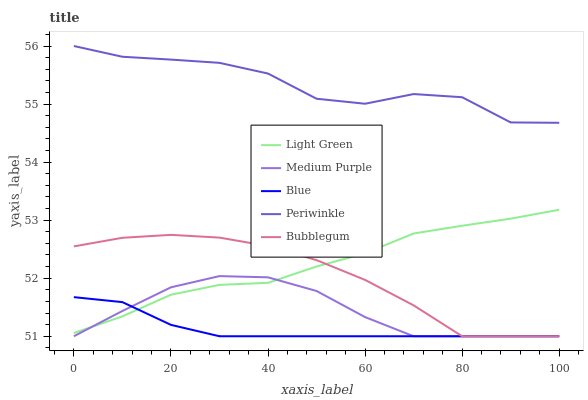Does Blue have the minimum area under the curve?
Answer yes or no. Yes. Does Periwinkle have the maximum area under the curve?
Answer yes or no. Yes. Does Periwinkle have the minimum area under the curve?
Answer yes or no. No. Does Blue have the maximum area under the curve?
Answer yes or no. No. Is Blue the smoothest?
Answer yes or no. Yes. Is Periwinkle the roughest?
Answer yes or no. Yes. Is Periwinkle the smoothest?
Answer yes or no. No. Is Blue the roughest?
Answer yes or no. No. Does Medium Purple have the lowest value?
Answer yes or no. Yes. Does Periwinkle have the lowest value?
Answer yes or no. No. Does Periwinkle have the highest value?
Answer yes or no. Yes. Does Blue have the highest value?
Answer yes or no. No. Is Bubblegum less than Periwinkle?
Answer yes or no. Yes. Is Periwinkle greater than Blue?
Answer yes or no. Yes. Does Blue intersect Medium Purple?
Answer yes or no. Yes. Is Blue less than Medium Purple?
Answer yes or no. No. Is Blue greater than Medium Purple?
Answer yes or no. No. Does Bubblegum intersect Periwinkle?
Answer yes or no. No. 